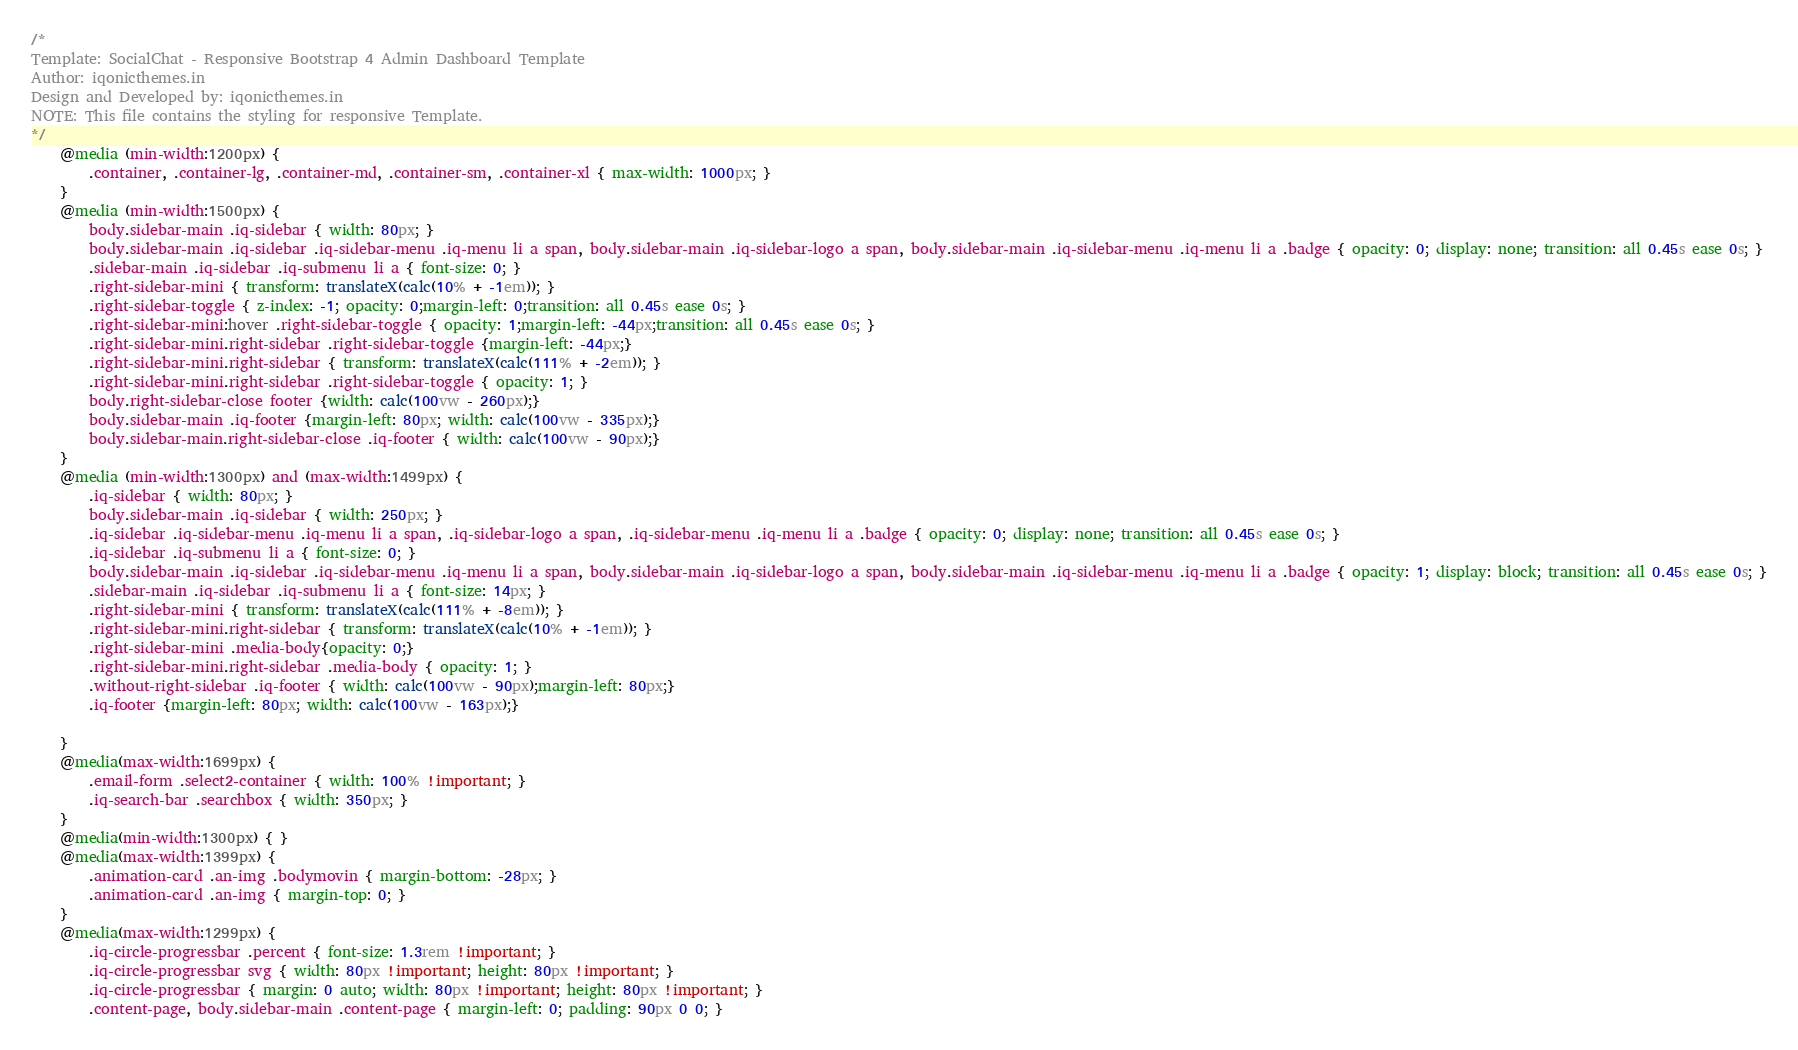<code> <loc_0><loc_0><loc_500><loc_500><_CSS_>/*
Template: SocialChat - Responsive Bootstrap 4 Admin Dashboard Template
Author: iqonicthemes.in
Design and Developed by: iqonicthemes.in
NOTE: This file contains the styling for responsive Template.
*/
	@media (min-width:1200px) {
		.container, .container-lg, .container-md, .container-sm, .container-xl { max-width: 1000px; }
	}
	@media (min-width:1500px) {
		body.sidebar-main .iq-sidebar { width: 80px; }
		body.sidebar-main .iq-sidebar .iq-sidebar-menu .iq-menu li a span, body.sidebar-main .iq-sidebar-logo a span, body.sidebar-main .iq-sidebar-menu .iq-menu li a .badge { opacity: 0; display: none; transition: all 0.45s ease 0s; }
		.sidebar-main .iq-sidebar .iq-submenu li a { font-size: 0; }
		.right-sidebar-mini { transform: translateX(calc(10% + -1em)); }
		.right-sidebar-toggle { z-index: -1; opacity: 0;margin-left: 0;transition: all 0.45s ease 0s; }
		.right-sidebar-mini:hover .right-sidebar-toggle { opacity: 1;margin-left: -44px;transition: all 0.45s ease 0s; }
		.right-sidebar-mini.right-sidebar .right-sidebar-toggle {margin-left: -44px;}
		.right-sidebar-mini.right-sidebar { transform: translateX(calc(111% + -2em)); }
		.right-sidebar-mini.right-sidebar .right-sidebar-toggle { opacity: 1; }
		body.right-sidebar-close footer {width: calc(100vw - 260px);}
		body.sidebar-main .iq-footer {margin-left: 80px; width: calc(100vw - 335px);}
		body.sidebar-main.right-sidebar-close .iq-footer { width: calc(100vw - 90px);}
	}
	@media (min-width:1300px) and (max-width:1499px) {
		.iq-sidebar { width: 80px; }
		body.sidebar-main .iq-sidebar { width: 250px; }
		.iq-sidebar .iq-sidebar-menu .iq-menu li a span, .iq-sidebar-logo a span, .iq-sidebar-menu .iq-menu li a .badge { opacity: 0; display: none; transition: all 0.45s ease 0s; }
		.iq-sidebar .iq-submenu li a { font-size: 0; }
		body.sidebar-main .iq-sidebar .iq-sidebar-menu .iq-menu li a span, body.sidebar-main .iq-sidebar-logo a span, body.sidebar-main .iq-sidebar-menu .iq-menu li a .badge { opacity: 1; display: block; transition: all 0.45s ease 0s; }
		.sidebar-main .iq-sidebar .iq-submenu li a { font-size: 14px; }
		.right-sidebar-mini { transform: translateX(calc(111% + -8em)); }
		.right-sidebar-mini.right-sidebar { transform: translateX(calc(10% + -1em)); }
		.right-sidebar-mini .media-body{opacity: 0;}
		.right-sidebar-mini.right-sidebar .media-body { opacity: 1; }
		.without-right-sidebar .iq-footer { width: calc(100vw - 90px);margin-left: 80px;}
		.iq-footer {margin-left: 80px; width: calc(100vw - 163px);}

	}
	@media(max-width:1699px) {
		.email-form .select2-container { width: 100% !important; }
		.iq-search-bar .searchbox { width: 350px; }
	}
	@media(min-width:1300px) { }
	@media(max-width:1399px) {
		.animation-card .an-img .bodymovin { margin-bottom: -28px; }
		.animation-card .an-img { margin-top: 0; }
	}
	@media(max-width:1299px) {
		.iq-circle-progressbar .percent { font-size: 1.3rem !important; }
		.iq-circle-progressbar svg { width: 80px !important; height: 80px !important; }
		.iq-circle-progressbar { margin: 0 auto; width: 80px !important; height: 80px !important; }
		.content-page, body.sidebar-main .content-page { margin-left: 0; padding: 90px 0 0; }</code> 